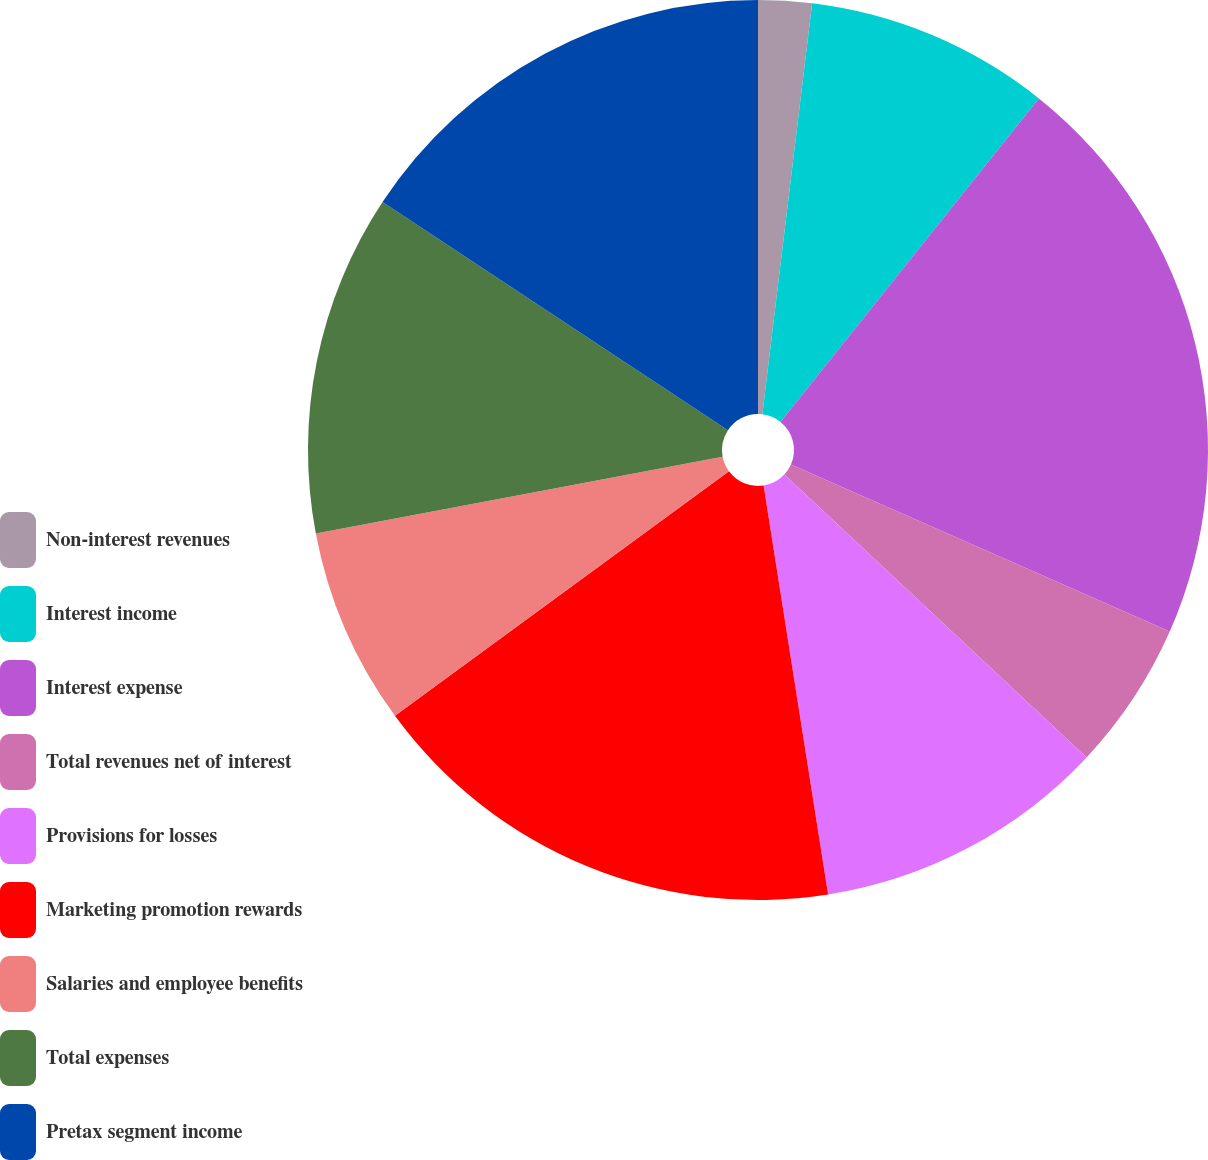Convert chart. <chart><loc_0><loc_0><loc_500><loc_500><pie_chart><fcel>Non-interest revenues<fcel>Interest income<fcel>Interest expense<fcel>Total revenues net of interest<fcel>Provisions for losses<fcel>Marketing promotion rewards<fcel>Salaries and employee benefits<fcel>Total expenses<fcel>Pretax segment income<nl><fcel>1.92%<fcel>8.81%<fcel>20.88%<fcel>5.36%<fcel>10.54%<fcel>17.43%<fcel>7.09%<fcel>12.26%<fcel>15.71%<nl></chart> 